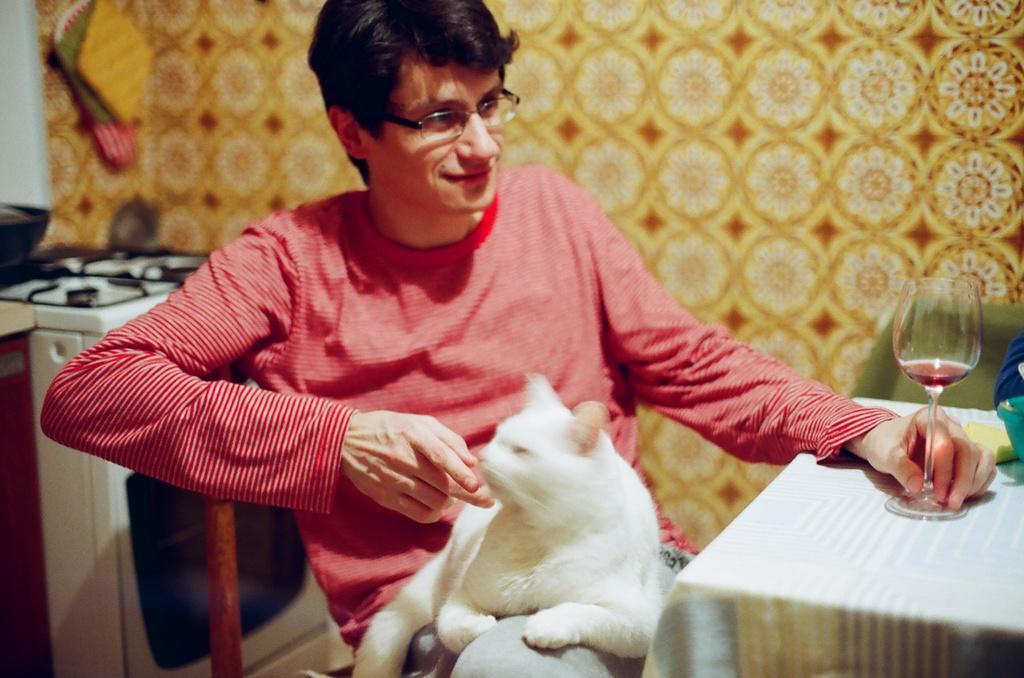Please provide a concise description of this image. In this picture I can observe a person sitting in the chair, wearing red color T shirt. The person is smiling. There is a white color cat sitting in his lap. In front of the person there is a table on which I can observe a wine glass. In the background there is a wall. 